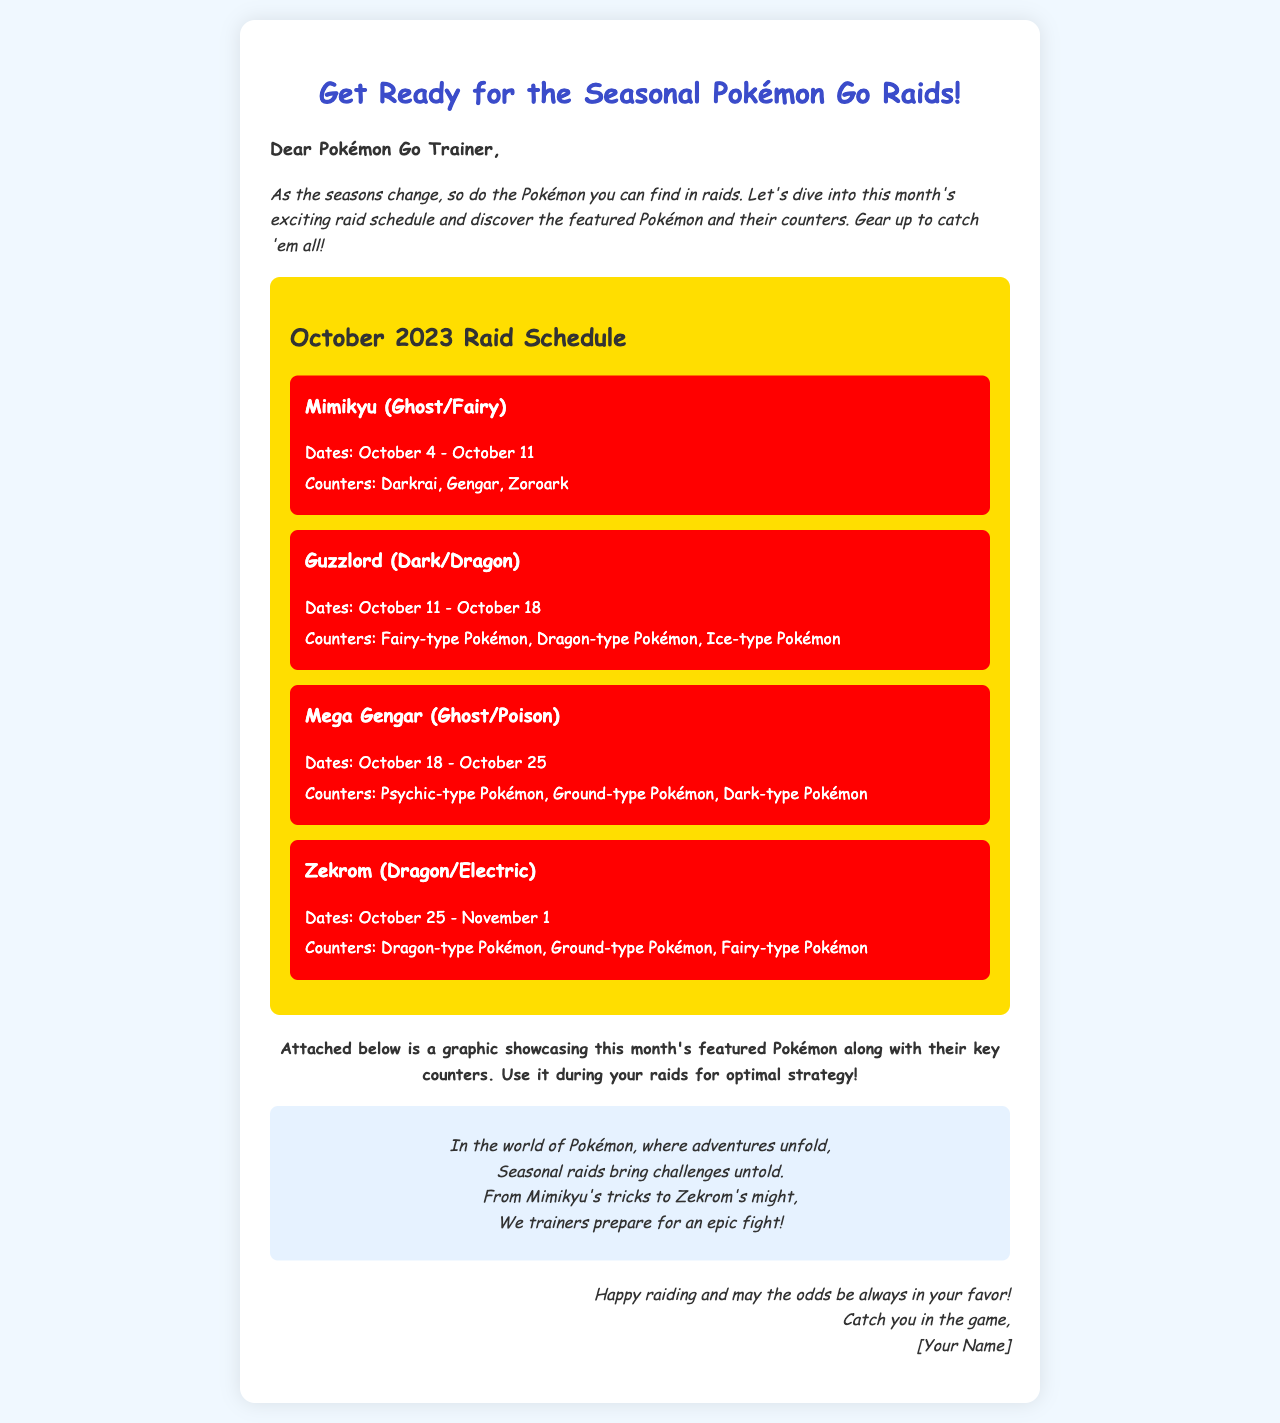What is the title of the document? The title of the document is mentioned in the `<title>` tag, which is "Seasonal Pokémon Go Raid Schedule".
Answer: Seasonal Pokémon Go Raid Schedule What is the first featured Pokémon in the October schedule? The first featured Pokémon is listed at the beginning of the raid schedule section.
Answer: Mimikyu What are the dates for Guzzlord raids? The dates for Guzzlord raids are stated in the corresponding section under "Dates".
Answer: October 11 - October 18 Which type of Pokémon counters Mega Gengar? The document lists specific types of Pokémon that counter Mega Gengar in its section.
Answer: Psychic-type Pokémon, Ground-type Pokémon, Dark-type Pokémon What should trainers refer to for optimal strategy during raids? The document mentions using a specific graphic for better raid strategies.
Answer: Attached graphic What is the greeting addressed to Pokémon Go Trainers? The greeting line is specifically stated at the beginning of the document.
Answer: Dear Pokémon Go Trainer 